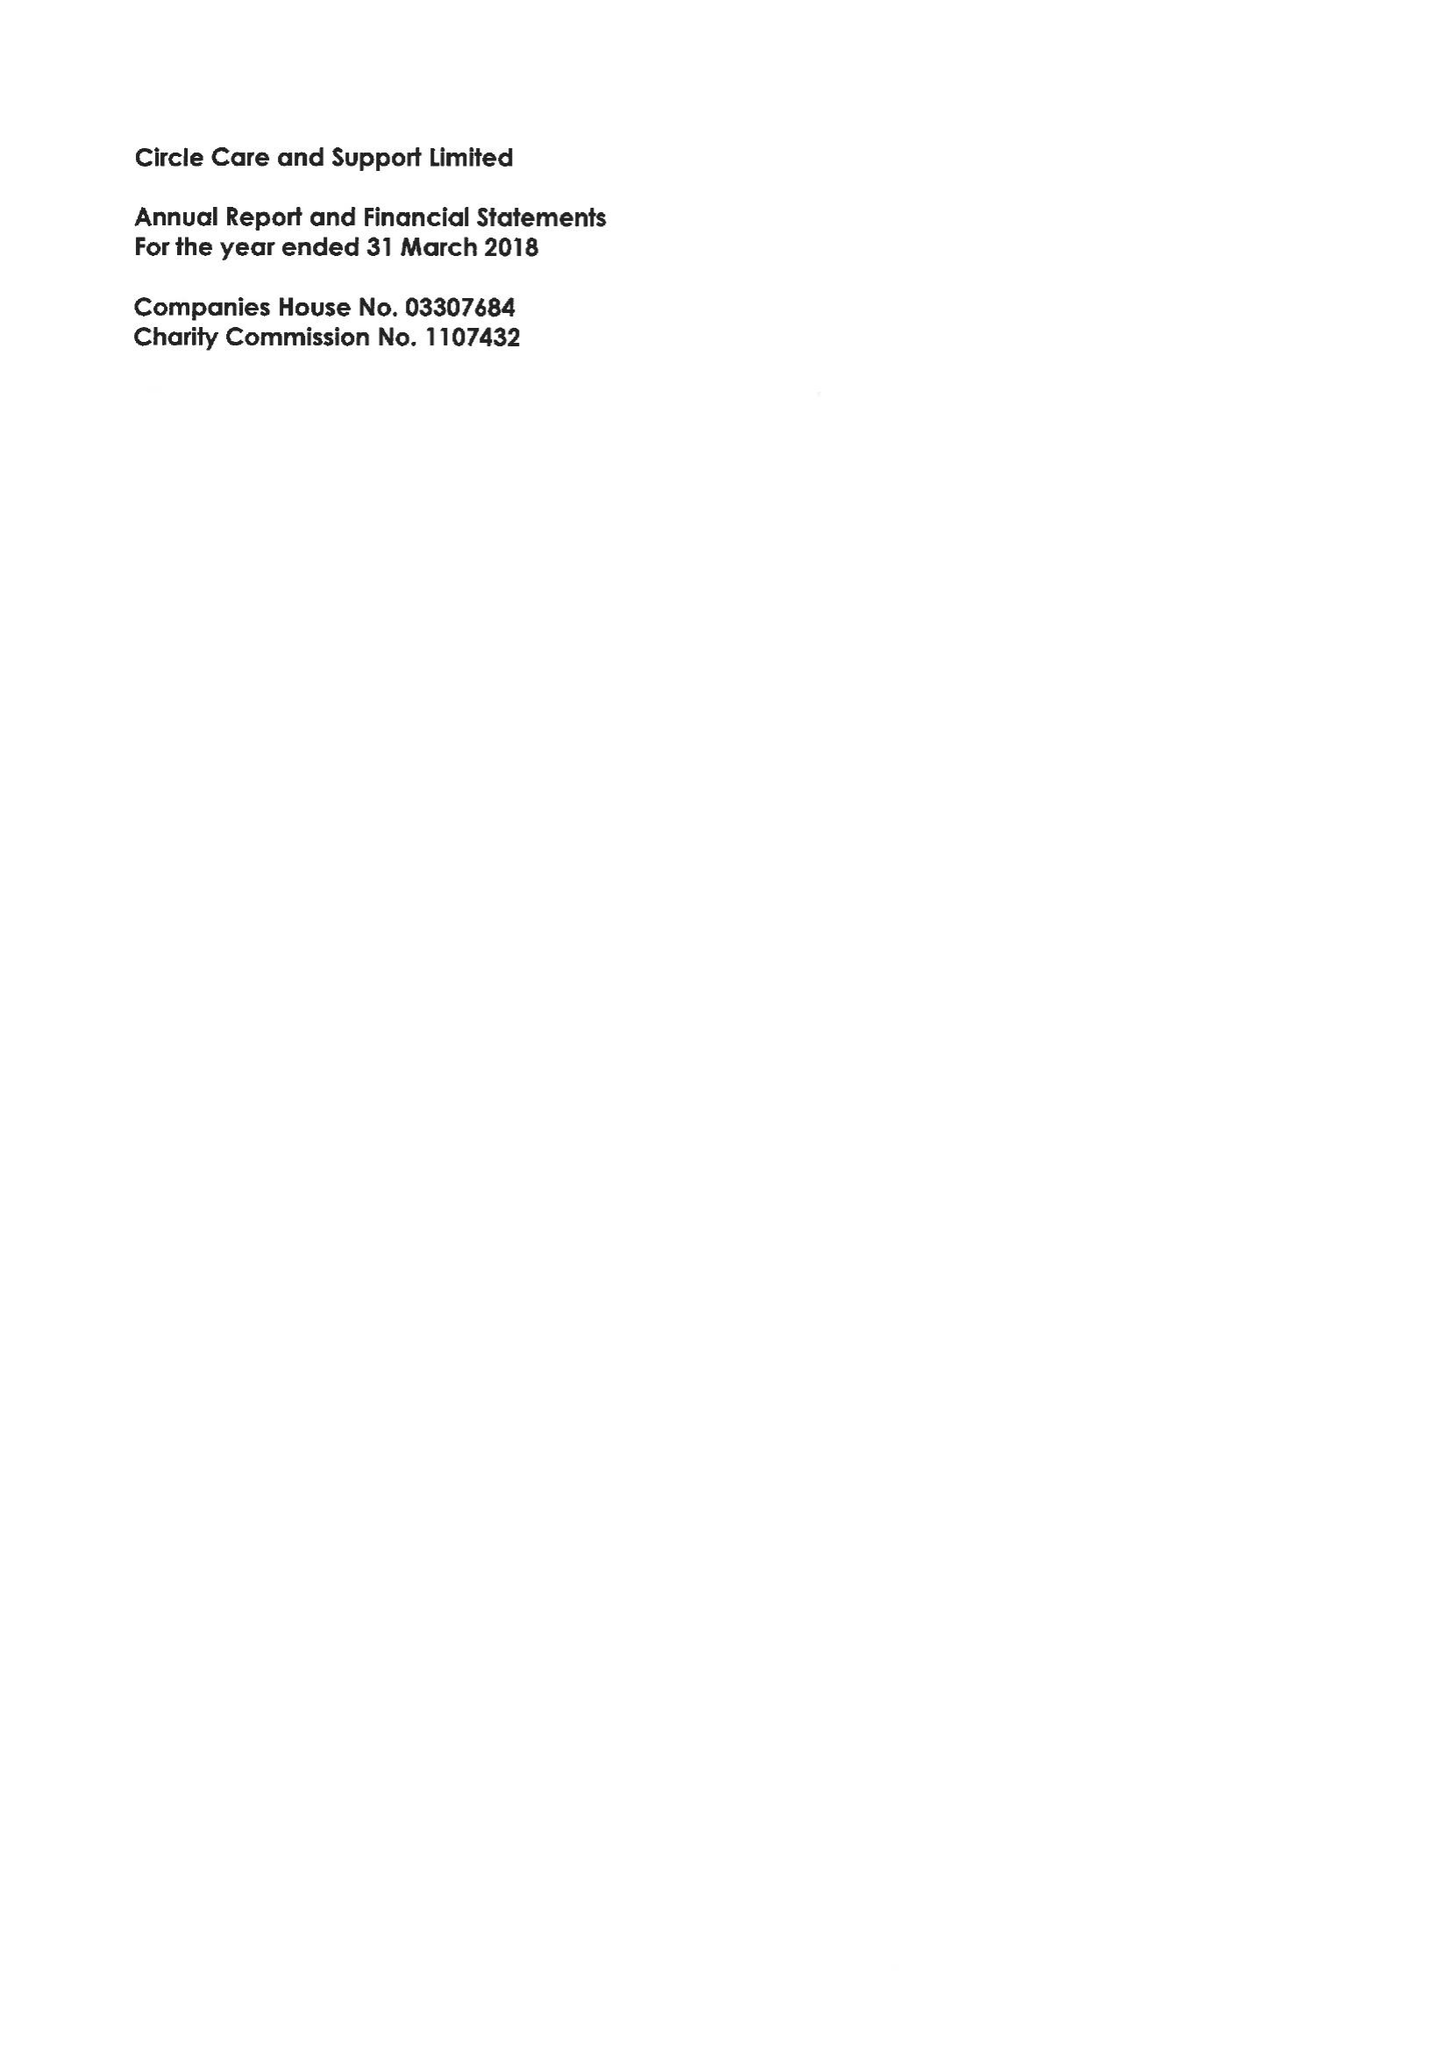What is the value for the address__street_line?
Answer the question using a single word or phrase. TOOLEY STREET 